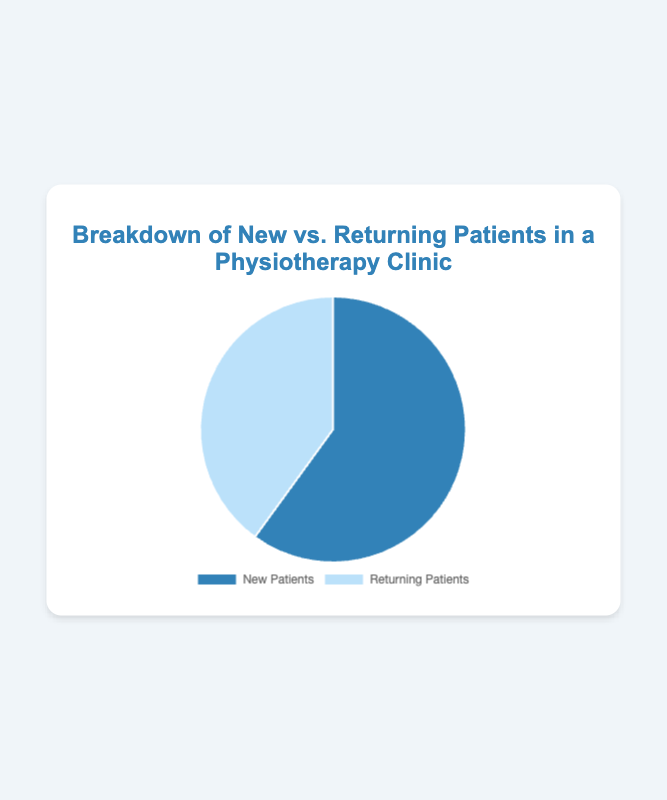What percentage of the patients are new? The pie chart shows two categories: New Patients and Returning Patients. The section labeled "New Patients" represents 60% of the total.
Answer: 60% What percentage of patients are returning? The pie chart shows two categories: New Patients and Returning Patients. The section labeled "Returning Patients" represents 40% of the total.
Answer: 40% Which category has a higher percentage of the total patients? Compare the percentages of both categories shown in the pie chart. New Patients have 60%, and Returning Patients have 40%. Therefore, New Patients have a higher percentage.
Answer: New Patients What is the difference in percentage between new and returning patients? To find the difference, subtract the percentage of Returning Patients (40%) from that of New Patients (60%). So, 60% - 40% = 20%.
Answer: 20% If the total number of patients is 100, how many of them are new patients? To find the number of new patients, calculate 60% of 100 patients. 60% of 100 is 60 (0.60 * 100 = 60).
Answer: 60 What is the ratio of new patients to returning patients in the clinic? The pie chart shows 60% new patients and 40% returning patients. To find the ratio, divide 60 by 40. Simplifying 60:40 gives a ratio of 3:2.
Answer: 3:2 If the total number of patients is 200, how many of them are returning patients? To find the number of returning patients, calculate 40% of 200. 40% of 200 is 80 (0.40 * 200 = 80).
Answer: 80 Which section of the pie chart is represented by the color blue? The pie chart uses different colors for each category. The section for New Patients is typically represented by the color blue.
Answer: New Patients Which section of the pie chart is larger, and what does it represent? Visually compare the sizes of the pie chart sections. The larger section represents 60%, which is for New Patients.
Answer: New Patients, 60% By what factor is the proportion of new patients greater than that of returning patients? To determine the factor, divide the percentage of New Patients by the percentage of Returning Patients. So, 60% divided by 40% is 1.5. New Patients are 1.5 times the proportion of Returning Patients.
Answer: 1.5x 